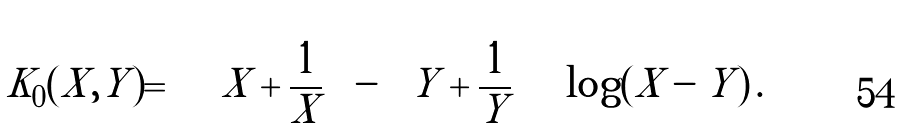<formula> <loc_0><loc_0><loc_500><loc_500>K _ { 0 } ( X , Y ) = \left [ \left ( X + \frac { 1 } { X } \right ) - \left ( Y + \frac { 1 } { Y } \right ) \right ] \log ( X - Y ) \, .</formula> 